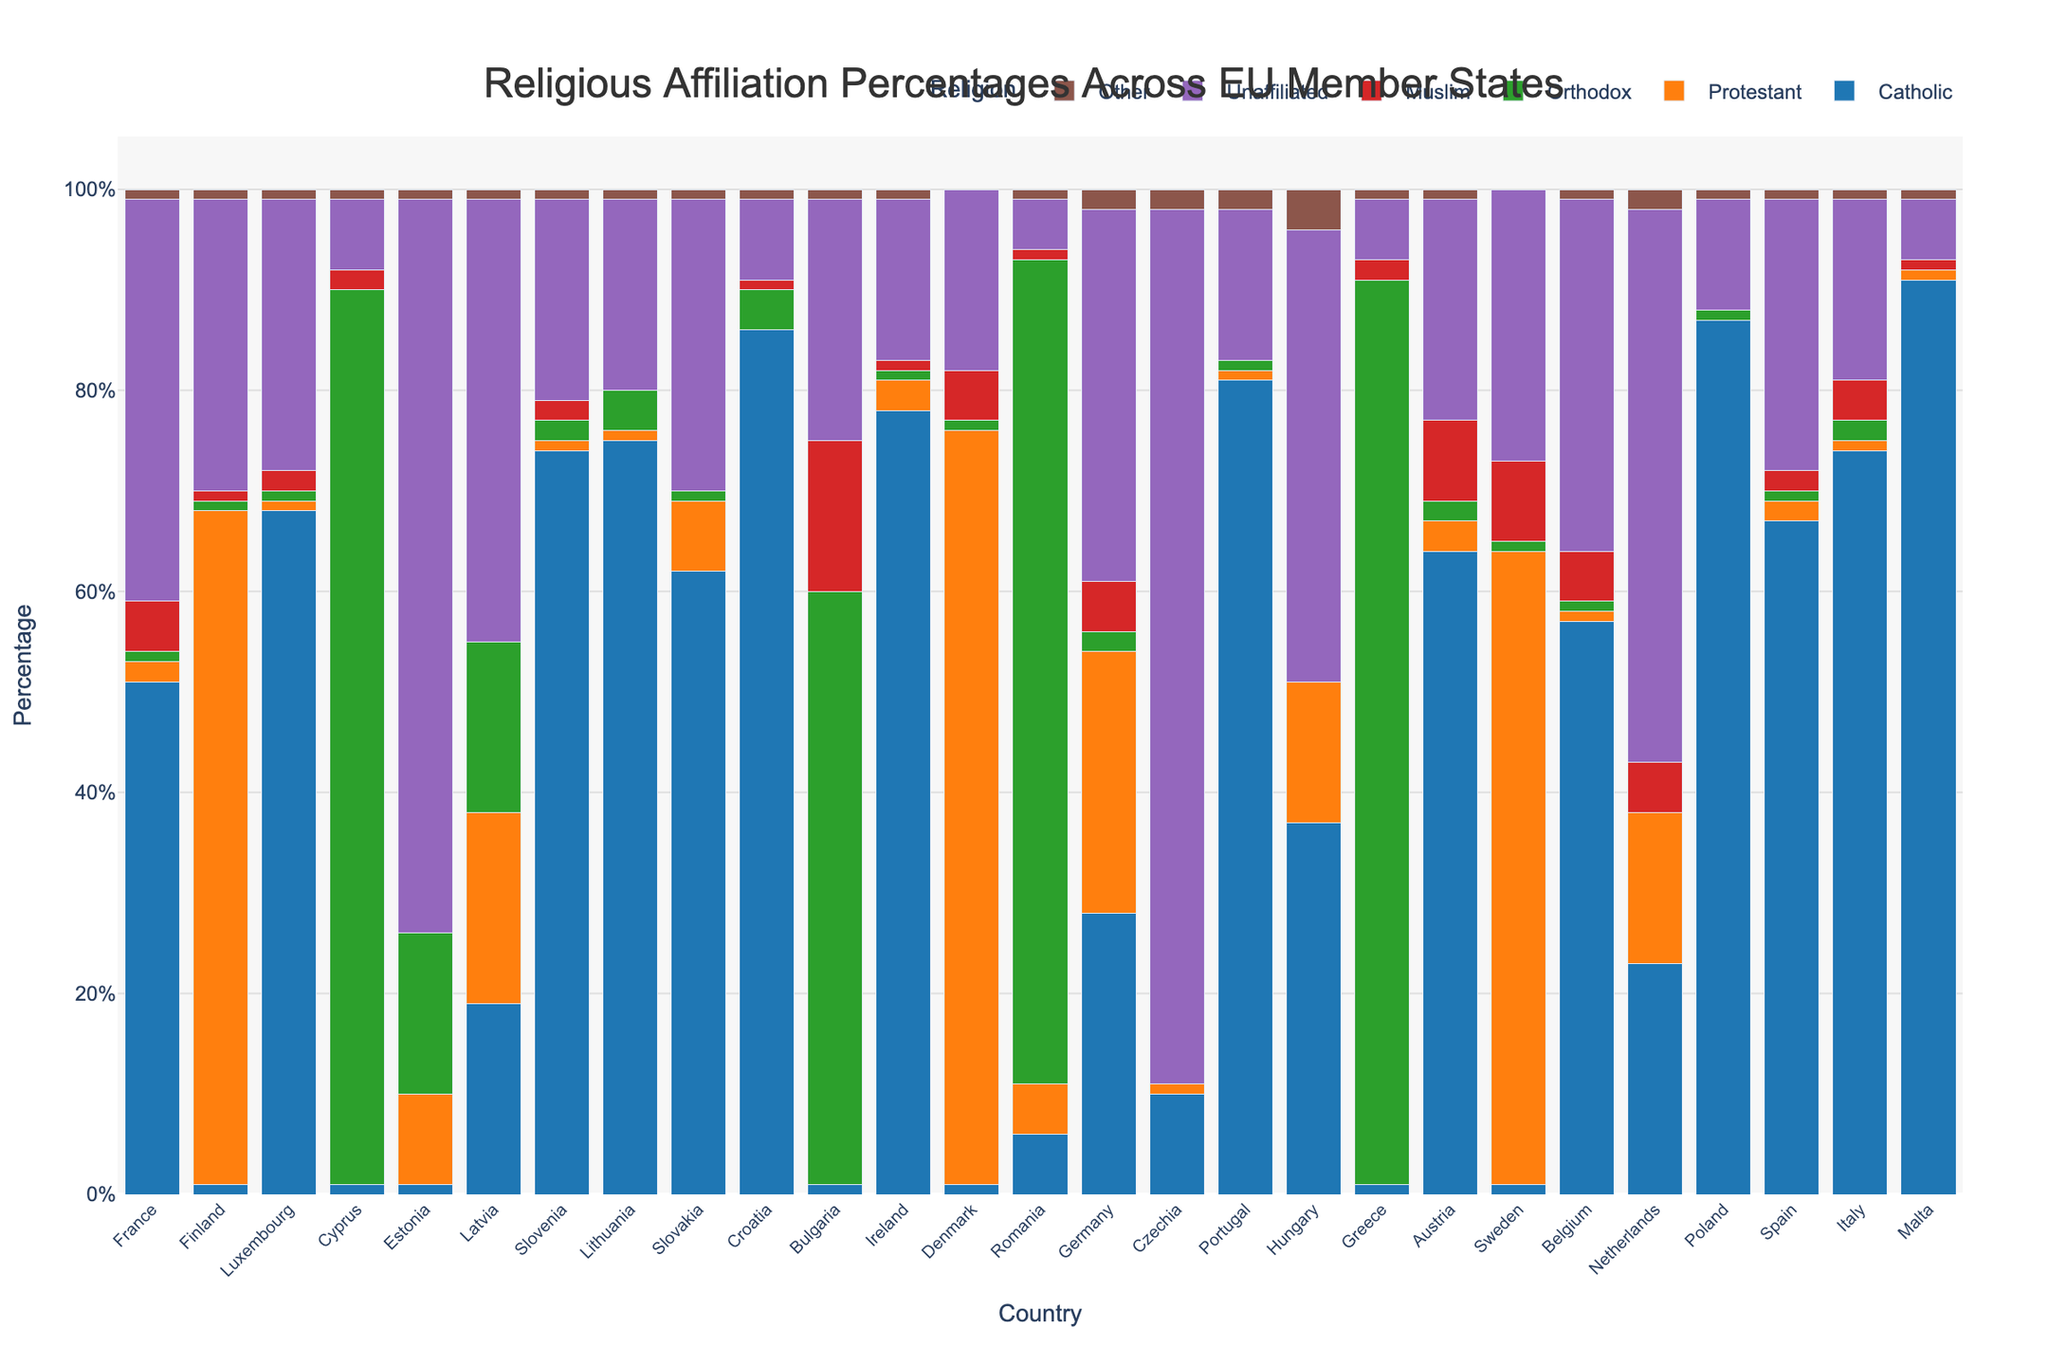Which country has the highest percentage of Catholics? By examining the heights of the bars representing Catholic percentages for each country in the stacked bar chart, Poland has the highest bar for Catholics.
Answer: Poland Which countries show more than 50% of their population as unaffiliated? Look for the bars representing the 'Unaffiliated' category and check if their heights exceed 50%. The countries fulfilling this criterion are Czechia and Estonia.
Answer: Czechia, Estonia How does the percentage of Protestants in Sweden compare to that in Germany? Compare the heights of the bars representing Protestants in Sweden and Germany. Sweden's Protestant bar is higher at 63%, while Germany's is at 26%.
Answer: Sweden > Germany What is the combined percentage of Muslims in Belgium and Austria? Add the percentages of Muslims in Belgium (5%) and Austria (8%). Their combined percentage is 5% + 8% = 13%.
Answer: 13% What is the difference in percentage of Orthodox Christians between Greece and Romania? Subtract the percentage of Orthodox Christians in Romania (82%) from that in Greece (90%). The difference is 90% - 82% = 8%.
Answer: 8% Which country has the most balanced distribution of religious affiliations, and how do you determine it? A balanced distribution means no single religion dominates. Hungary with its relatively even distribution among several categories (37% Catholic, 14% Protestant, 0% Orthodox, 45% Unaffiliated, 4% Other) appears most balanced.
Answer: Hungary What is the second most common religion in France? Examine France's bars and identify the second highest. After Catholic (51%), Unaffiliated is next at 40%.
Answer: Unaffiliated Which country has the highest percentage of Orthodox Christians, and what is their proportion? By locating the tallest bar for the Orthodox category, Greece has the highest proportion at 90%.
Answer: Greece (90%) How many countries have a Muslim population percentage higher than 5%? Identify the bars representing Muslim populations greater than 5%. The countries are Sweden, Austria, Belgium, Bulgaria, and Germany, which makes it 5 countries.
Answer: 5 What is the total percentage of Christians (sum of Catholic, Protestant, Orthodox) in Italy? Add the percentages for Catholics (74%), Protestants (1%), and Orthodox Christians (2%) in Italy. The total is 74% + 1% + 2% = 77%.
Answer: 77% 